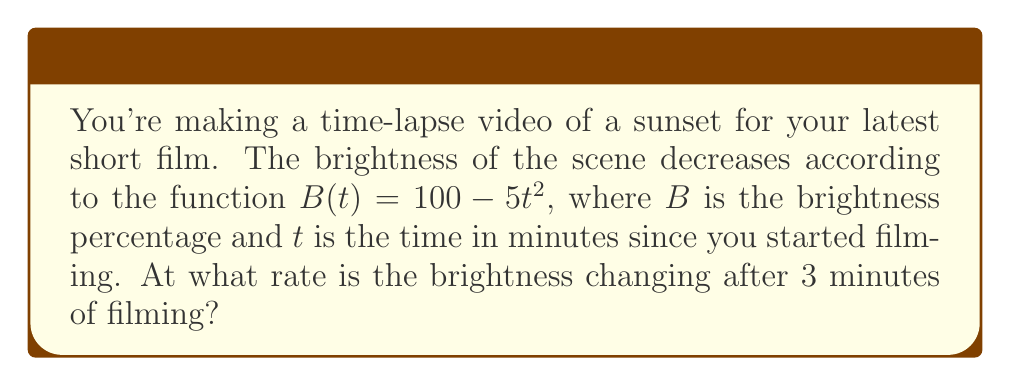Provide a solution to this math problem. Let's approach this step-by-step:

1) The brightness function is given by $B(t) = 100 - 5t^2$

2) To find the rate of change of brightness, we need to find the derivative of $B(t)$ with respect to $t$:

   $$\frac{dB}{dt} = \frac{d}{dt}(100 - 5t^2)$$

3) Using the power rule of differentiation:

   $$\frac{dB}{dt} = 0 - 5 \cdot 2t = -10t$$

4) This derivative represents the instantaneous rate of change of brightness at any time $t$.

5) We're asked about the rate of change after 3 minutes, so we need to evaluate $\frac{dB}{dt}$ at $t = 3$:

   $$\left.\frac{dB}{dt}\right|_{t=3} = -10(3) = -30$$

6) The negative sign indicates that the brightness is decreasing.

Therefore, after 3 minutes of filming, the brightness is decreasing at a rate of 30 percentage points per minute.
Answer: -30 percentage points per minute 